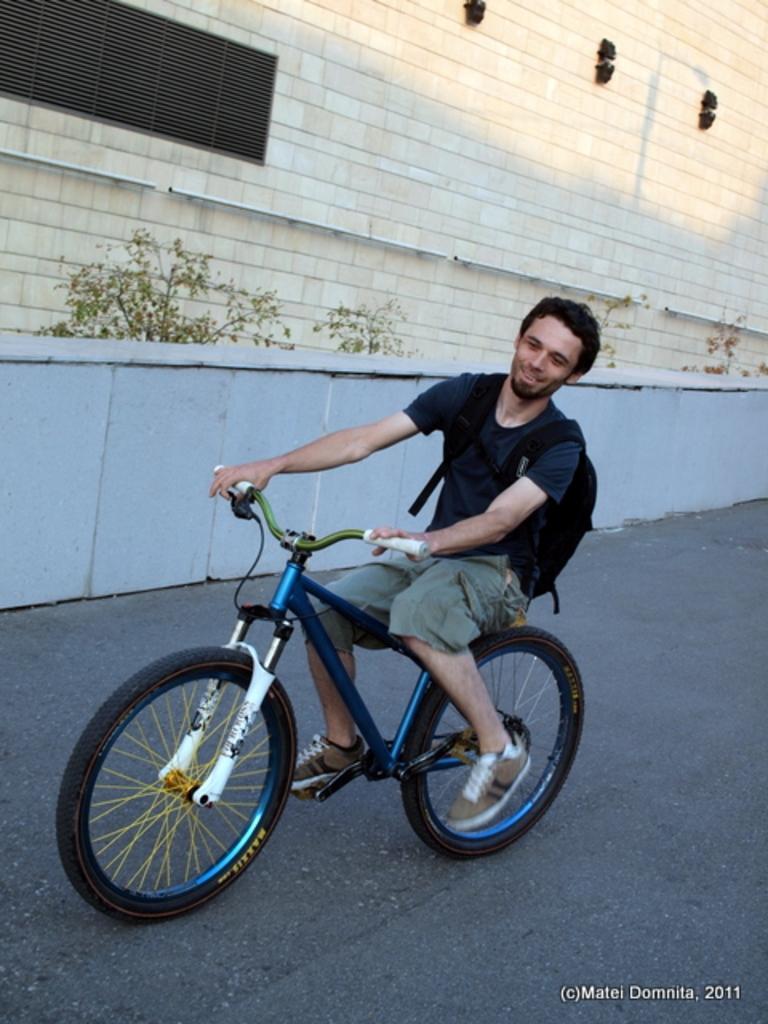In one or two sentences, can you explain what this image depicts? In the picture we can find a man riding a bicycle he is wearing a black bag. And the cycle is blue in colour. In the background we can find a wall, some plants. 